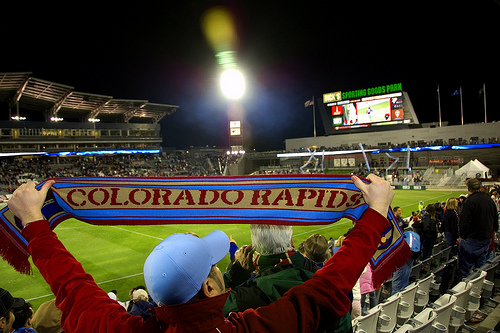<image>
Is there a man on the colorado rapids? No. The man is not positioned on the colorado rapids. They may be near each other, but the man is not supported by or resting on top of the colorado rapids. 